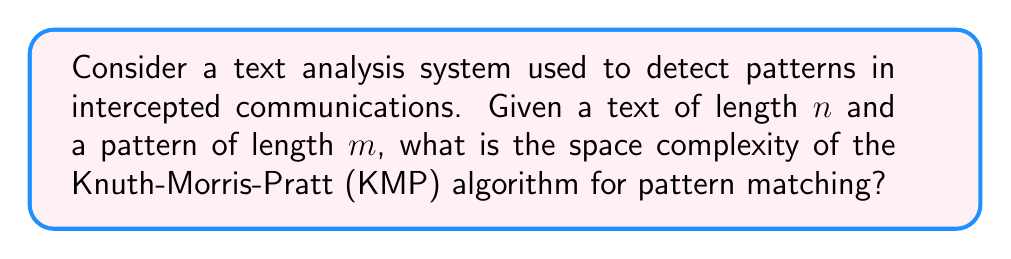Provide a solution to this math problem. To understand the space complexity of the Knuth-Morris-Pratt (KMP) algorithm, we need to consider the additional data structures it uses beyond the input text and pattern:

1. Input storage:
   - The text of length $n$ is typically considered part of the input, not counting towards the algorithm's space complexity.
   - The pattern of length $m$ is also part of the input.

2. Failure function (also known as the prefix function):
   - The KMP algorithm precomputes a failure function to optimize the matching process.
   - This function is stored in an array of length $m$.
   - Each element in this array requires $O(\log m)$ bits to store an integer up to $m$.

3. Variables:
   - The algorithm uses a constant number of variables for indexing and comparison, which require $O(\log n)$ bits each.

The dominant factor in the space complexity is the failure function array. Therefore, the total space complexity can be calculated as follows:

$$O(m \cdot \log m)$$

This is because we need $m$ elements, each requiring $O(\log m)$ bits to store.

It's worth noting that in practice, for most reasonable text sizes, the $\log m$ factor is often considered constant, simplifying the space complexity to $O(m)$. However, for a precise theoretical analysis, we include the $\log m$ factor.
Answer: The space complexity of the Knuth-Morris-Pratt (KMP) algorithm for pattern matching is $O(m \cdot \log m)$, where $m$ is the length of the pattern. 